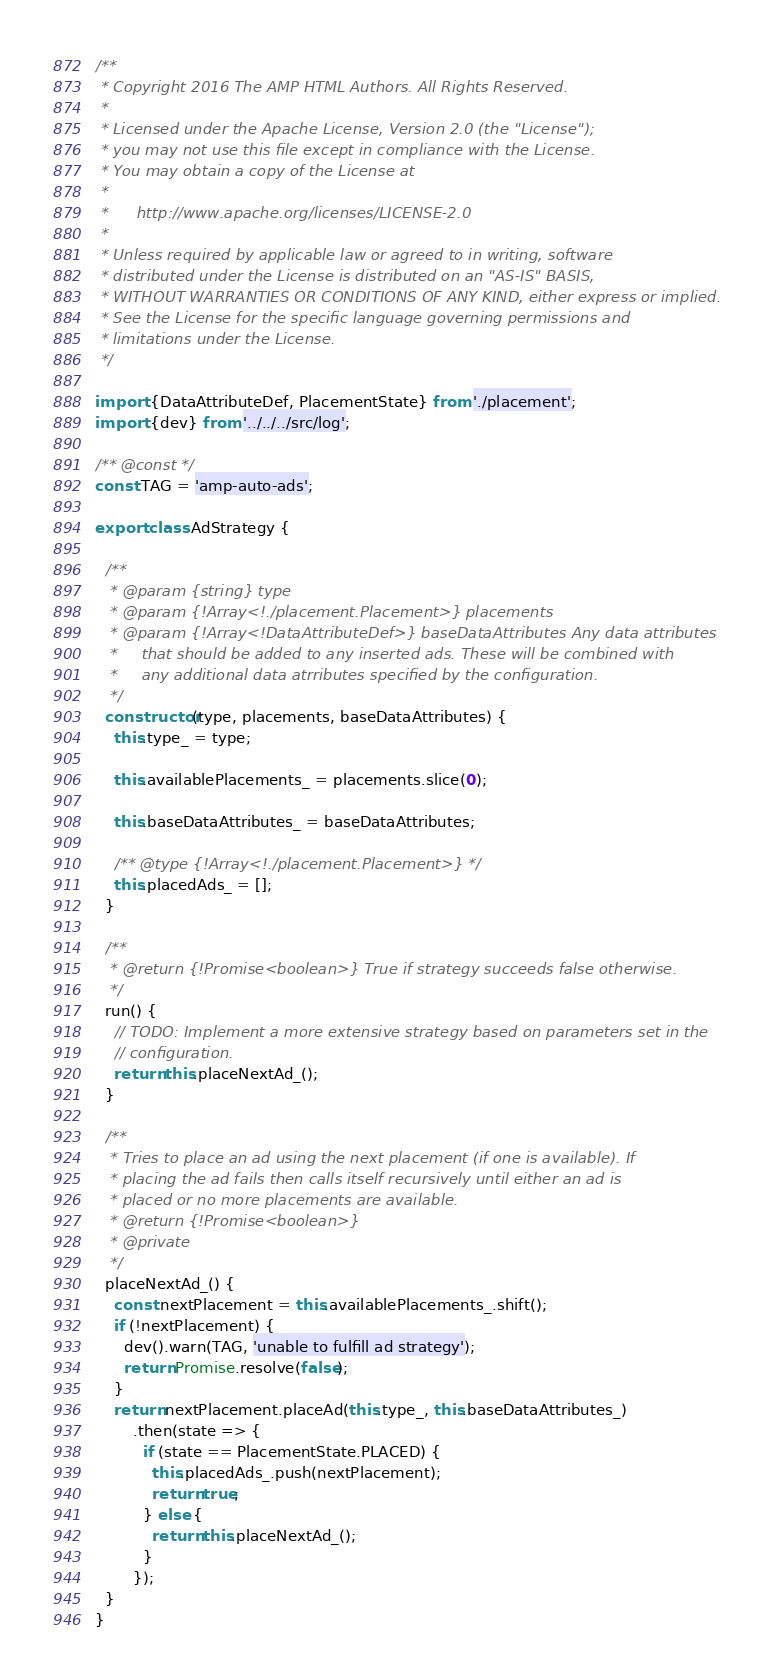<code> <loc_0><loc_0><loc_500><loc_500><_JavaScript_>/**
 * Copyright 2016 The AMP HTML Authors. All Rights Reserved.
 *
 * Licensed under the Apache License, Version 2.0 (the "License");
 * you may not use this file except in compliance with the License.
 * You may obtain a copy of the License at
 *
 *      http://www.apache.org/licenses/LICENSE-2.0
 *
 * Unless required by applicable law or agreed to in writing, software
 * distributed under the License is distributed on an "AS-IS" BASIS,
 * WITHOUT WARRANTIES OR CONDITIONS OF ANY KIND, either express or implied.
 * See the License for the specific language governing permissions and
 * limitations under the License.
 */

import {DataAttributeDef, PlacementState} from './placement';
import {dev} from '../../../src/log';

/** @const */
const TAG = 'amp-auto-ads';

export class AdStrategy {

  /**
   * @param {string} type
   * @param {!Array<!./placement.Placement>} placements
   * @param {!Array<!DataAttributeDef>} baseDataAttributes Any data attributes
   *     that should be added to any inserted ads. These will be combined with
   *     any additional data atrributes specified by the configuration.
   */
  constructor(type, placements, baseDataAttributes) {
    this.type_ = type;

    this.availablePlacements_ = placements.slice(0);

    this.baseDataAttributes_ = baseDataAttributes;

    /** @type {!Array<!./placement.Placement>} */
    this.placedAds_ = [];
  }

  /**
   * @return {!Promise<boolean>} True if strategy succeeds false otherwise.
   */
  run() {
    // TODO: Implement a more extensive strategy based on parameters set in the
    // configuration.
    return this.placeNextAd_();
  }

  /**
   * Tries to place an ad using the next placement (if one is available). If
   * placing the ad fails then calls itself recursively until either an ad is
   * placed or no more placements are available.
   * @return {!Promise<boolean>}
   * @private
   */
  placeNextAd_() {
    const nextPlacement = this.availablePlacements_.shift();
    if (!nextPlacement) {
      dev().warn(TAG, 'unable to fulfill ad strategy');
      return Promise.resolve(false);
    }
    return nextPlacement.placeAd(this.type_, this.baseDataAttributes_)
        .then(state => {
          if (state == PlacementState.PLACED) {
            this.placedAds_.push(nextPlacement);
            return true;
          } else {
            return this.placeNextAd_();
          }
        });
  }
}
</code> 